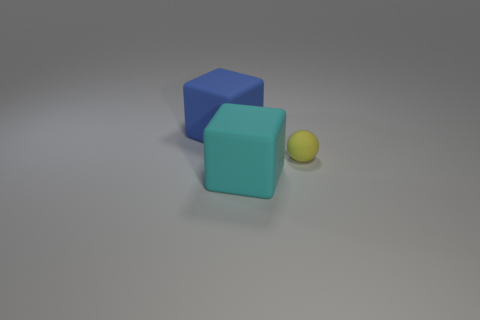There is a large blue thing that is the same shape as the cyan matte thing; what is it made of?
Provide a succinct answer. Rubber. Does the rubber object in front of the tiny yellow matte ball have the same color as the large object that is behind the tiny ball?
Give a very brief answer. No. Is there a gray cylinder of the same size as the yellow object?
Keep it short and to the point. No. What is the material of the object that is left of the small yellow ball and behind the large cyan rubber block?
Provide a short and direct response. Rubber. How many rubber objects are large things or big cyan objects?
Provide a succinct answer. 2. There is a tiny object that is the same material as the large blue thing; what is its shape?
Make the answer very short. Sphere. How many large matte things are behind the cyan rubber cube and on the right side of the large blue rubber block?
Give a very brief answer. 0. Is there any other thing that has the same shape as the cyan matte object?
Give a very brief answer. Yes. There is a cube that is in front of the big blue rubber thing; what is its size?
Provide a succinct answer. Large. What number of other things are the same color as the small sphere?
Your answer should be very brief. 0. 